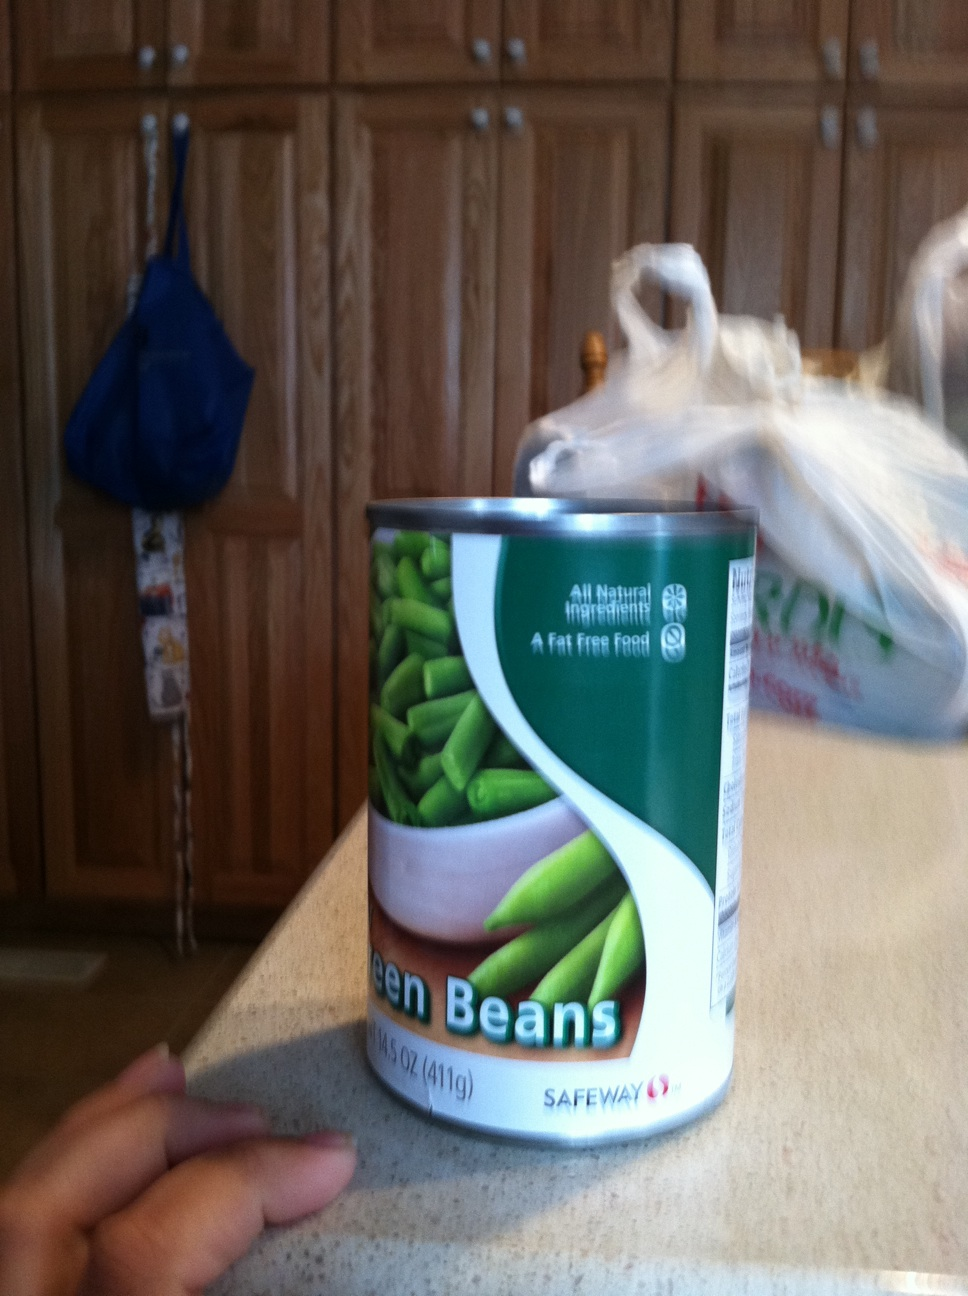What is in this can? The can contains green beans, which are all natural ingredients and marked as a fat-free food, as per the label displayed on the can. 